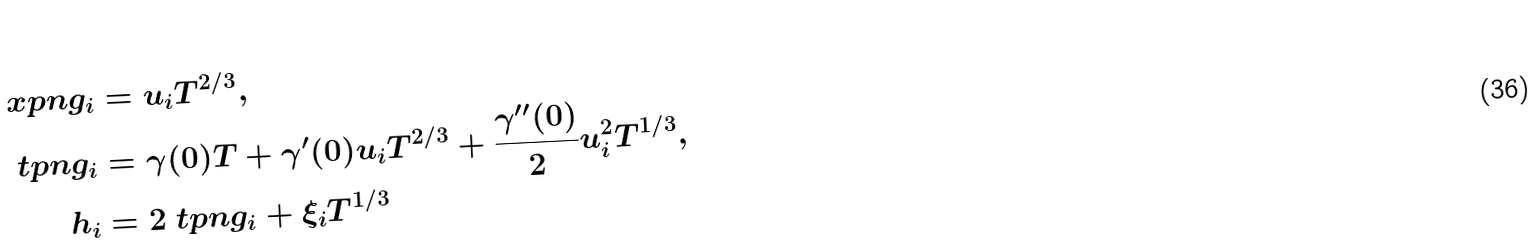<formula> <loc_0><loc_0><loc_500><loc_500>\ x p n g _ { i } & = u _ { i } T ^ { 2 / 3 } , \\ \ t p n g _ { i } & = \gamma ( 0 ) T + \gamma ^ { \prime } ( 0 ) u _ { i } T ^ { 2 / 3 } + \frac { \gamma ^ { \prime \prime } ( 0 ) } { 2 } u _ { i } ^ { 2 } T ^ { 1 / 3 } , \\ h _ { i } & = 2 \ t p n g _ { i } + \xi _ { i } T ^ { 1 / 3 }</formula> 